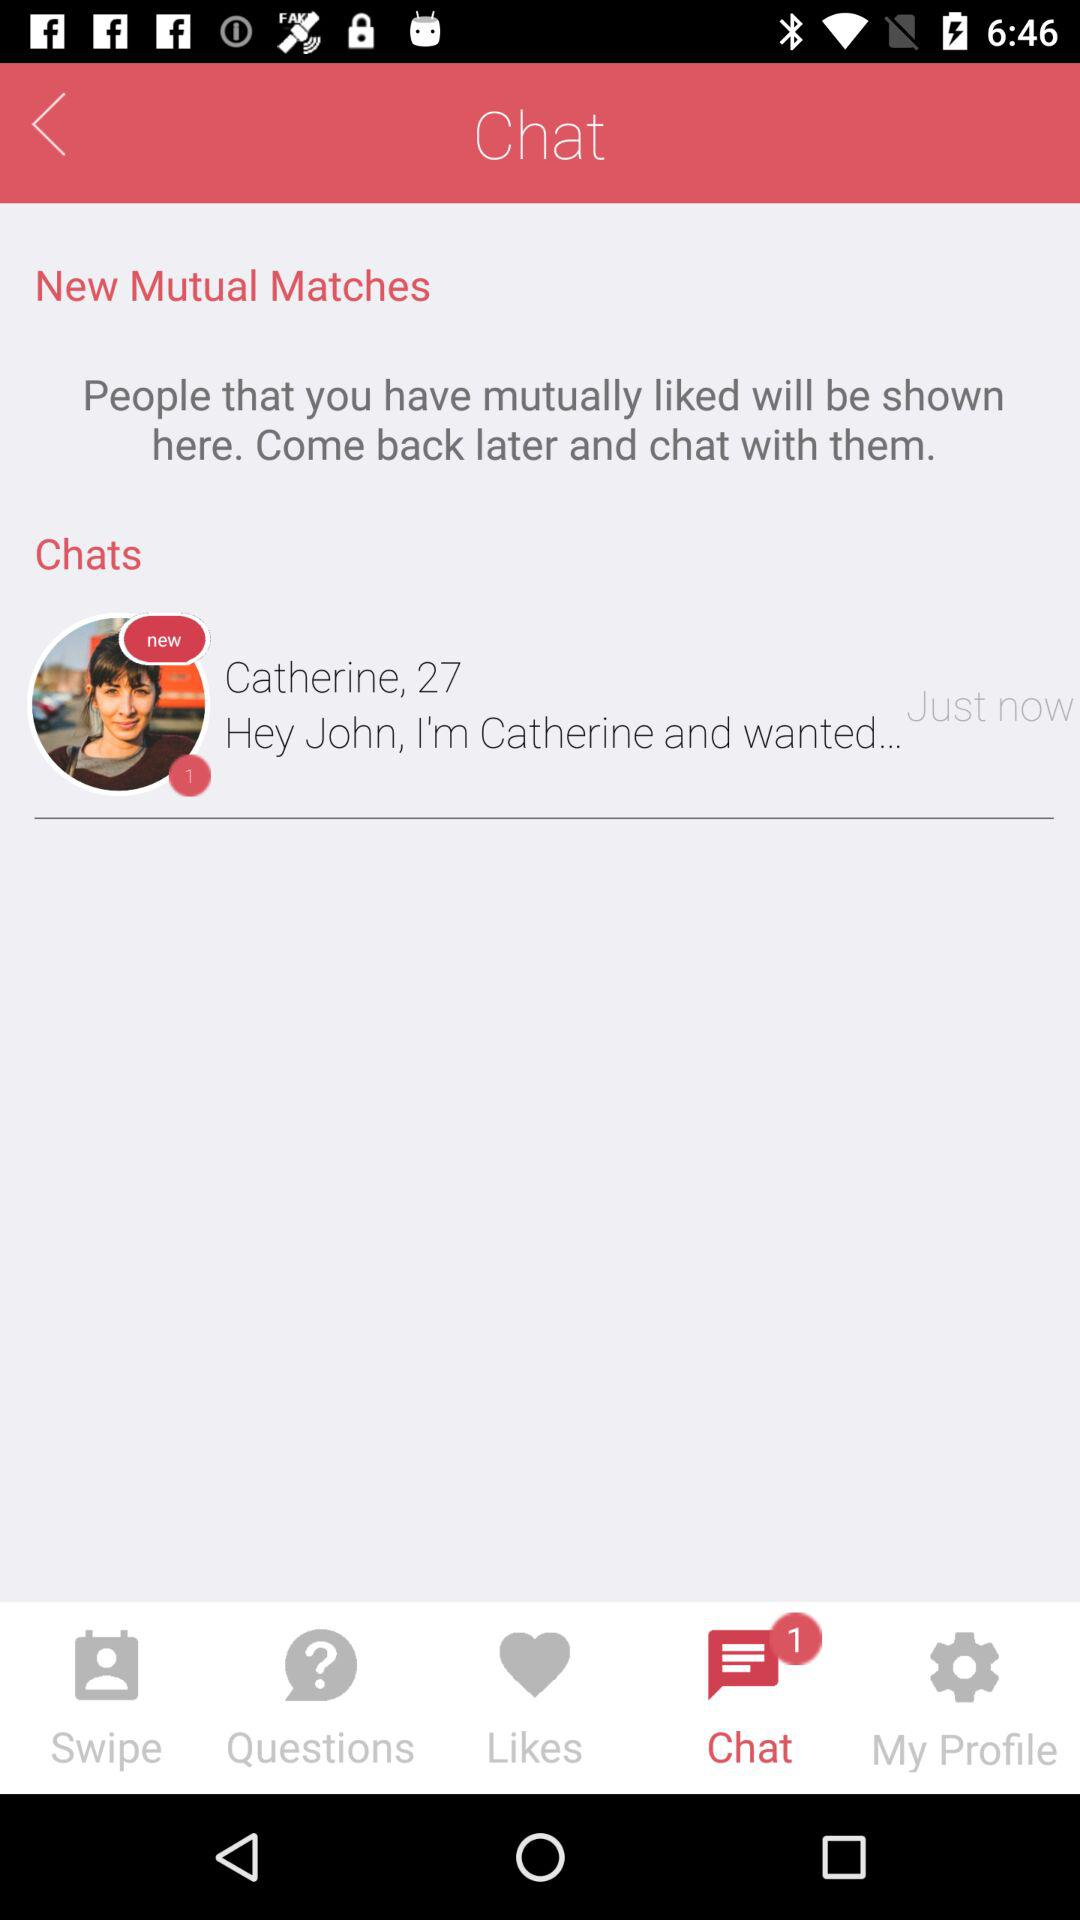What tab is selected? The selected tab is "Chat". 